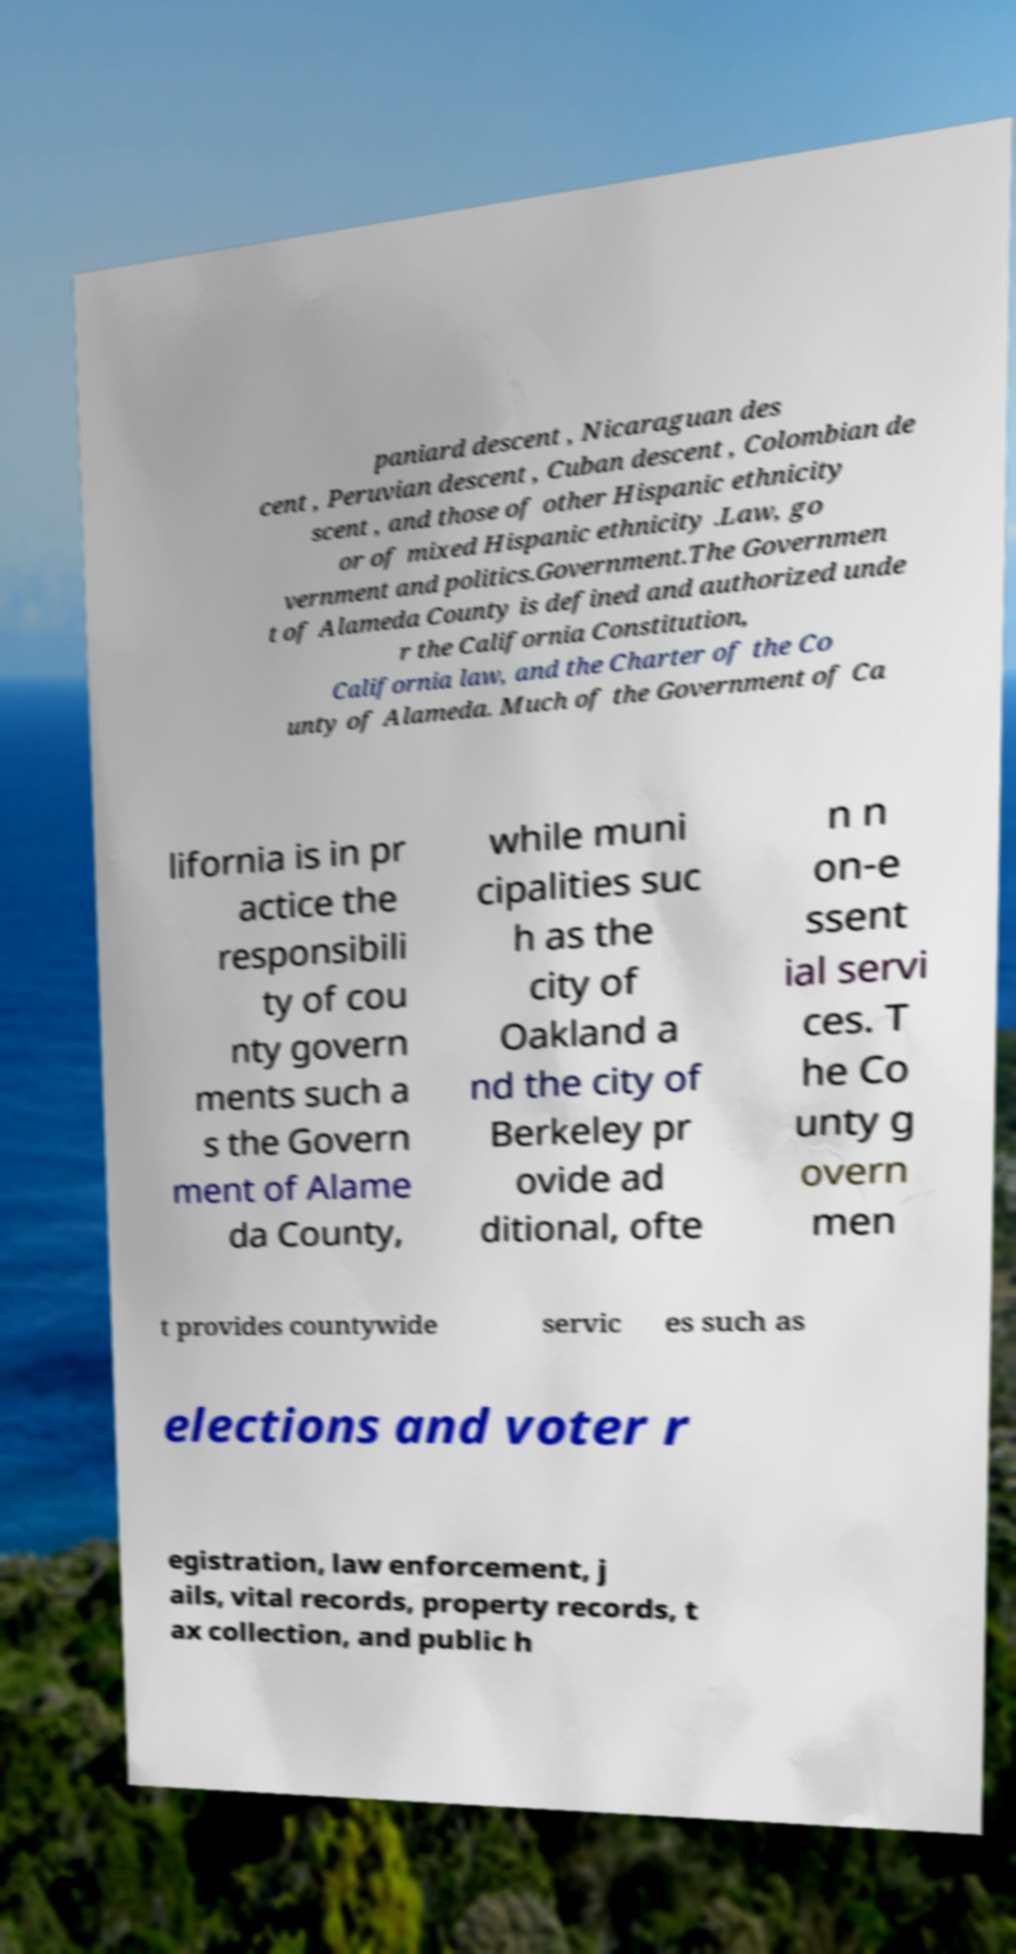Could you assist in decoding the text presented in this image and type it out clearly? paniard descent , Nicaraguan des cent , Peruvian descent , Cuban descent , Colombian de scent , and those of other Hispanic ethnicity or of mixed Hispanic ethnicity .Law, go vernment and politics.Government.The Governmen t of Alameda County is defined and authorized unde r the California Constitution, California law, and the Charter of the Co unty of Alameda. Much of the Government of Ca lifornia is in pr actice the responsibili ty of cou nty govern ments such a s the Govern ment of Alame da County, while muni cipalities suc h as the city of Oakland a nd the city of Berkeley pr ovide ad ditional, ofte n n on-e ssent ial servi ces. T he Co unty g overn men t provides countywide servic es such as elections and voter r egistration, law enforcement, j ails, vital records, property records, t ax collection, and public h 